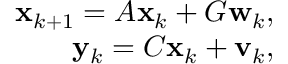<formula> <loc_0><loc_0><loc_500><loc_500>\begin{array} { r } { x _ { k + 1 } = A x _ { k } + G w _ { k } , } \\ { y _ { k } = C x _ { k } + v _ { k } , } \end{array}</formula> 